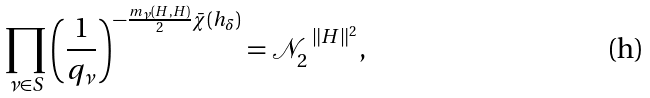<formula> <loc_0><loc_0><loc_500><loc_500>\prod _ { \nu \in S } \left ( \frac { 1 } { q _ { \nu } } \right ) ^ { - \frac { m _ { \nu } ( H , H ) } { 2 } \bar { \chi } ( h _ { \delta } ) } = \mathcal { N } _ { 2 } ^ { \ \| H \| ^ { 2 } } ,</formula> 